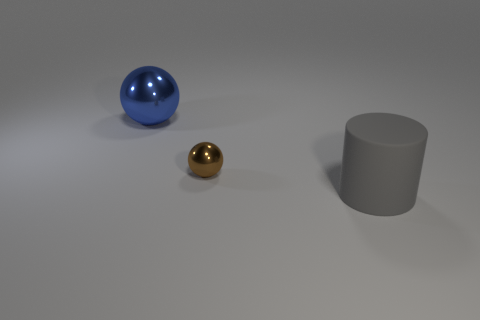Add 3 large cylinders. How many objects exist? 6 Subtract 1 spheres. How many spheres are left? 1 Subtract all blue spheres. How many spheres are left? 1 Subtract 0 cyan blocks. How many objects are left? 3 Subtract all cylinders. How many objects are left? 2 Subtract all green spheres. Subtract all yellow cubes. How many spheres are left? 2 Subtract all gray cylinders. How many gray spheres are left? 0 Subtract all big gray objects. Subtract all tiny shiny blocks. How many objects are left? 2 Add 2 tiny brown shiny things. How many tiny brown shiny things are left? 3 Add 1 small brown things. How many small brown things exist? 2 